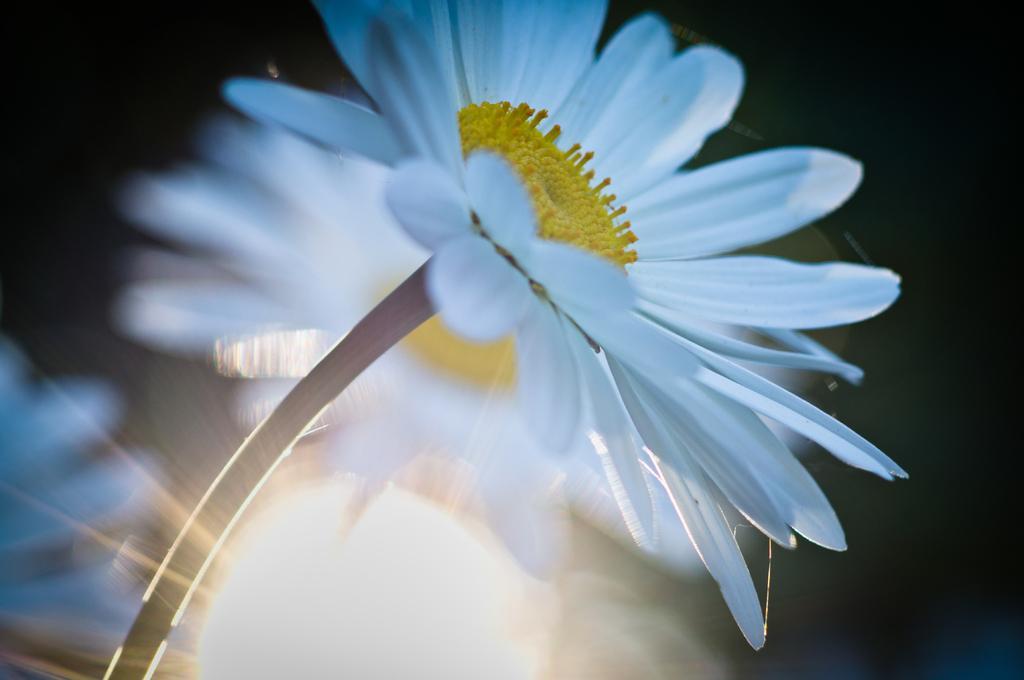Describe this image in one or two sentences. This image consists of a flower. It is in white color. 